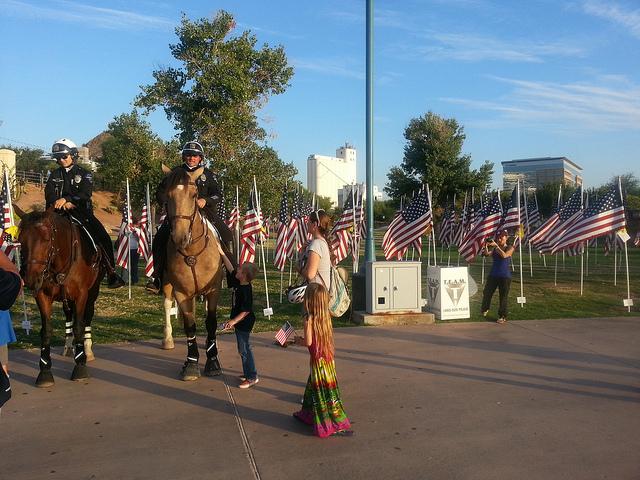Where are the flags?
Short answer required. Background. Are these American flags?
Concise answer only. Yes. What type of people are ,on the horses?
Keep it brief. Police. 